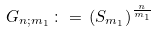Convert formula to latex. <formula><loc_0><loc_0><loc_500><loc_500>G _ { n ; m _ { 1 } } \, \colon = \, ( S _ { m _ { 1 } } ) ^ { \frac { n } { m _ { 1 } } }</formula> 